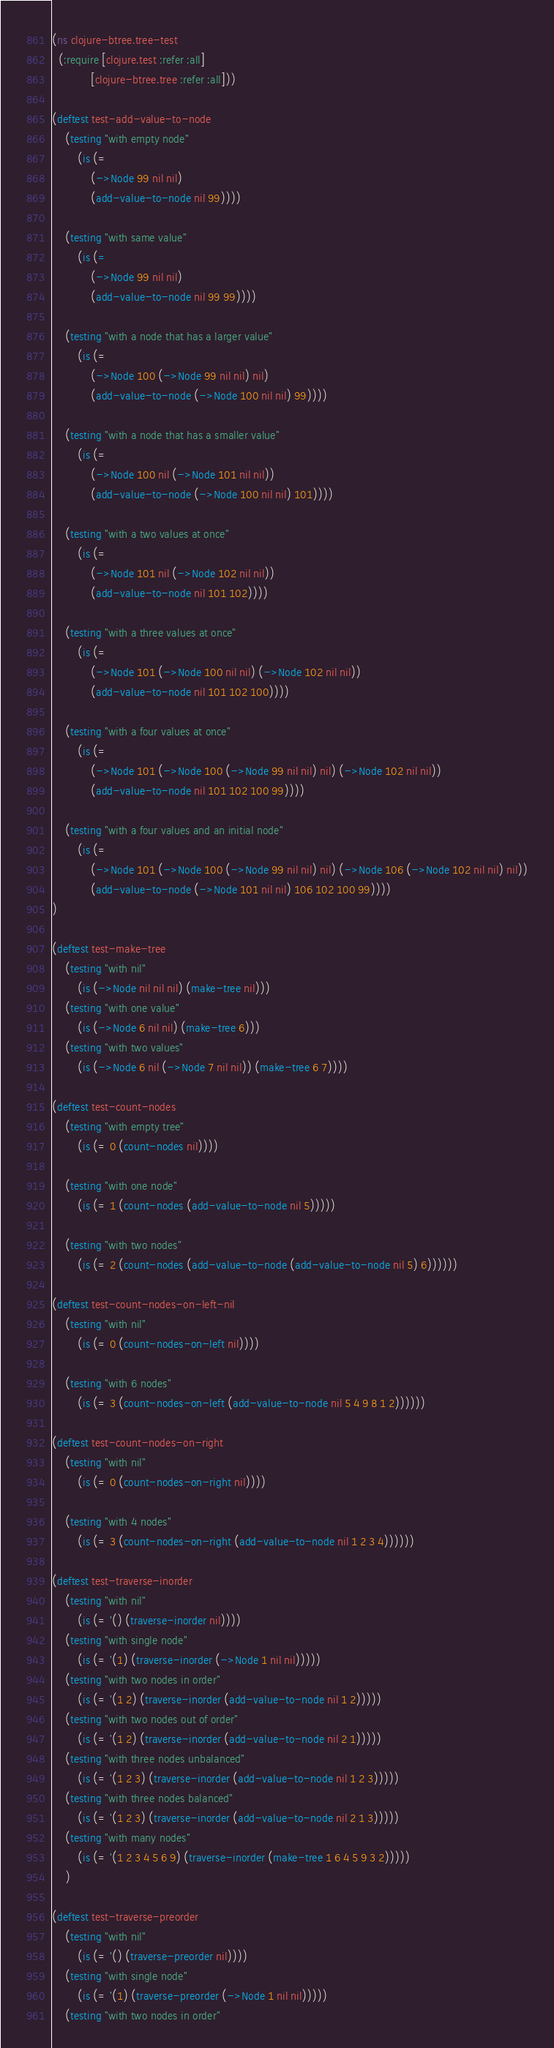<code> <loc_0><loc_0><loc_500><loc_500><_Clojure_>(ns clojure-btree.tree-test
  (:require [clojure.test :refer :all]
            [clojure-btree.tree :refer :all]))

(deftest test-add-value-to-node
    (testing "with empty node"
        (is (= 
            (->Node 99 nil nil)
            (add-value-to-node nil 99))))

    (testing "with same value"
        (is (=
            (->Node 99 nil nil)
            (add-value-to-node nil 99 99))))

    (testing "with a node that has a larger value"
        (is (= 
            (->Node 100 (->Node 99 nil nil) nil)
            (add-value-to-node (->Node 100 nil nil) 99))))

    (testing "with a node that has a smaller value"
        (is (= 
            (->Node 100 nil (->Node 101 nil nil))
            (add-value-to-node (->Node 100 nil nil) 101))))

    (testing "with a two values at once"
        (is (= 
            (->Node 101 nil (->Node 102 nil nil))
            (add-value-to-node nil 101 102))))

    (testing "with a three values at once"
        (is (= 
            (->Node 101 (->Node 100 nil nil) (->Node 102 nil nil))
            (add-value-to-node nil 101 102 100))))

    (testing "with a four values at once"
        (is (= 
            (->Node 101 (->Node 100 (->Node 99 nil nil) nil) (->Node 102 nil nil))
            (add-value-to-node nil 101 102 100 99))))

    (testing "with a four values and an initial node"
        (is (= 
            (->Node 101 (->Node 100 (->Node 99 nil nil) nil) (->Node 106 (->Node 102 nil nil) nil))
            (add-value-to-node (->Node 101 nil nil) 106 102 100 99))))
)

(deftest test-make-tree
    (testing "with nil"
        (is (->Node nil nil nil) (make-tree nil)))
    (testing "with one value"
        (is (->Node 6 nil nil) (make-tree 6)))
    (testing "with two values"
        (is (->Node 6 nil (->Node 7 nil nil)) (make-tree 6 7))))

(deftest test-count-nodes
    (testing "with empty tree"
        (is (= 0 (count-nodes nil))))

    (testing "with one node"
        (is (= 1 (count-nodes (add-value-to-node nil 5)))))

    (testing "with two nodes"
        (is (= 2 (count-nodes (add-value-to-node (add-value-to-node nil 5) 6))))))

(deftest test-count-nodes-on-left-nil
    (testing "with nil"
        (is (= 0 (count-nodes-on-left nil))))

    (testing "with 6 nodes"
        (is (= 3 (count-nodes-on-left (add-value-to-node nil 5 4 9 8 1 2))))))

(deftest test-count-nodes-on-right
    (testing "with nil"
        (is (= 0 (count-nodes-on-right nil))))

    (testing "with 4 nodes"
        (is (= 3 (count-nodes-on-right (add-value-to-node nil 1 2 3 4))))))

(deftest test-traverse-inorder
    (testing "with nil"
        (is (= '() (traverse-inorder nil))))
    (testing "with single node"
        (is (= '(1) (traverse-inorder (->Node 1 nil nil)))))
    (testing "with two nodes in order"
        (is (= '(1 2) (traverse-inorder (add-value-to-node nil 1 2)))))
    (testing "with two nodes out of order"
        (is (= '(1 2) (traverse-inorder (add-value-to-node nil 2 1)))))
    (testing "with three nodes unbalanced"
        (is (= '(1 2 3) (traverse-inorder (add-value-to-node nil 1 2 3)))))
    (testing "with three nodes balanced"
        (is (= '(1 2 3) (traverse-inorder (add-value-to-node nil 2 1 3)))))
    (testing "with many nodes"
        (is (= '(1 2 3 4 5 6 9) (traverse-inorder (make-tree 1 6 4 5 9 3 2)))))
    )

(deftest test-traverse-preorder
    (testing "with nil"
        (is (= '() (traverse-preorder nil))))
    (testing "with single node"
        (is (= '(1) (traverse-preorder (->Node 1 nil nil)))))
    (testing "with two nodes in order"</code> 